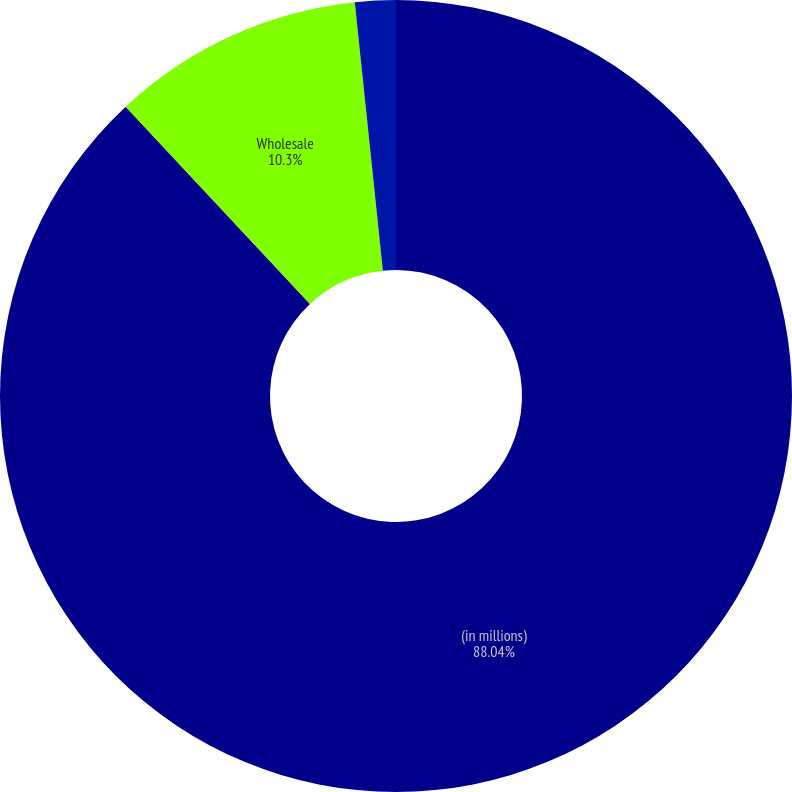Convert chart. <chart><loc_0><loc_0><loc_500><loc_500><pie_chart><fcel>(in millions)<fcel>Wholesale<fcel>Total provision for credit<nl><fcel>88.04%<fcel>10.3%<fcel>1.66%<nl></chart> 